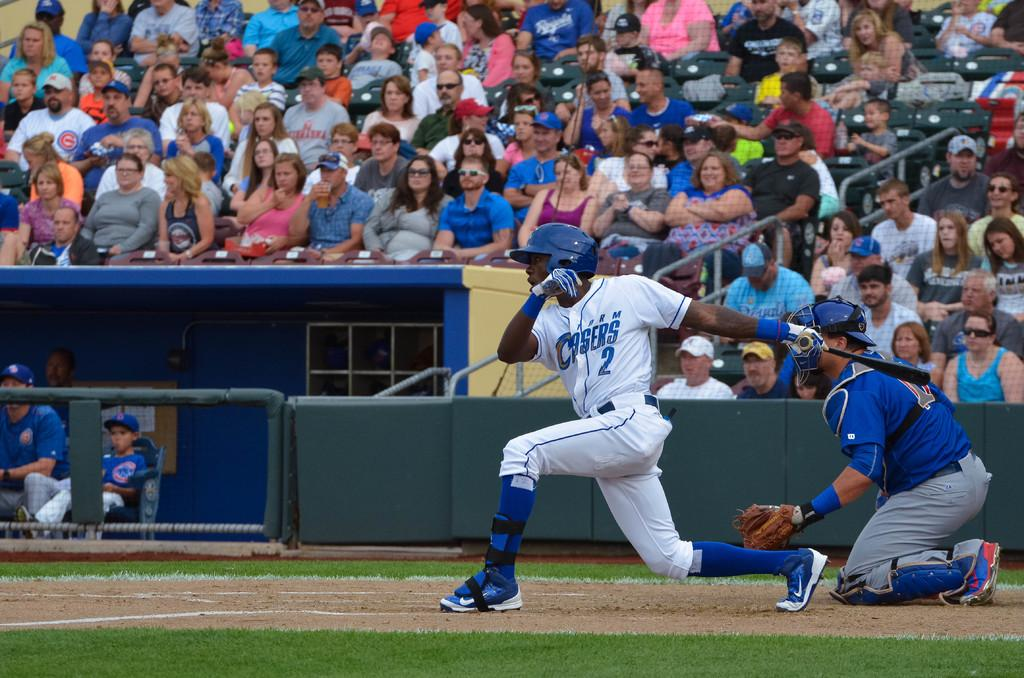<image>
Create a compact narrative representing the image presented. Player number 2 in white swings at a baseball. 